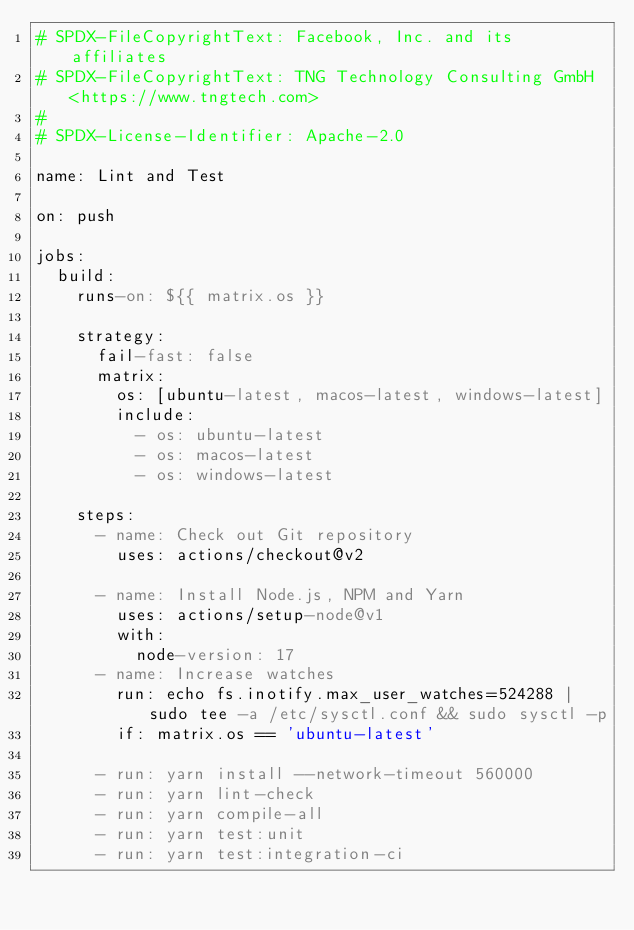<code> <loc_0><loc_0><loc_500><loc_500><_YAML_># SPDX-FileCopyrightText: Facebook, Inc. and its affiliates
# SPDX-FileCopyrightText: TNG Technology Consulting GmbH <https://www.tngtech.com>
#
# SPDX-License-Identifier: Apache-2.0

name: Lint and Test

on: push

jobs:
  build:
    runs-on: ${{ matrix.os }}

    strategy:
      fail-fast: false
      matrix:
        os: [ubuntu-latest, macos-latest, windows-latest]
        include:
          - os: ubuntu-latest
          - os: macos-latest
          - os: windows-latest

    steps:
      - name: Check out Git repository
        uses: actions/checkout@v2

      - name: Install Node.js, NPM and Yarn
        uses: actions/setup-node@v1
        with:
          node-version: 17
      - name: Increase watches
        run: echo fs.inotify.max_user_watches=524288 | sudo tee -a /etc/sysctl.conf && sudo sysctl -p
        if: matrix.os == 'ubuntu-latest'

      - run: yarn install --network-timeout 560000
      - run: yarn lint-check
      - run: yarn compile-all
      - run: yarn test:unit
      - run: yarn test:integration-ci
</code> 